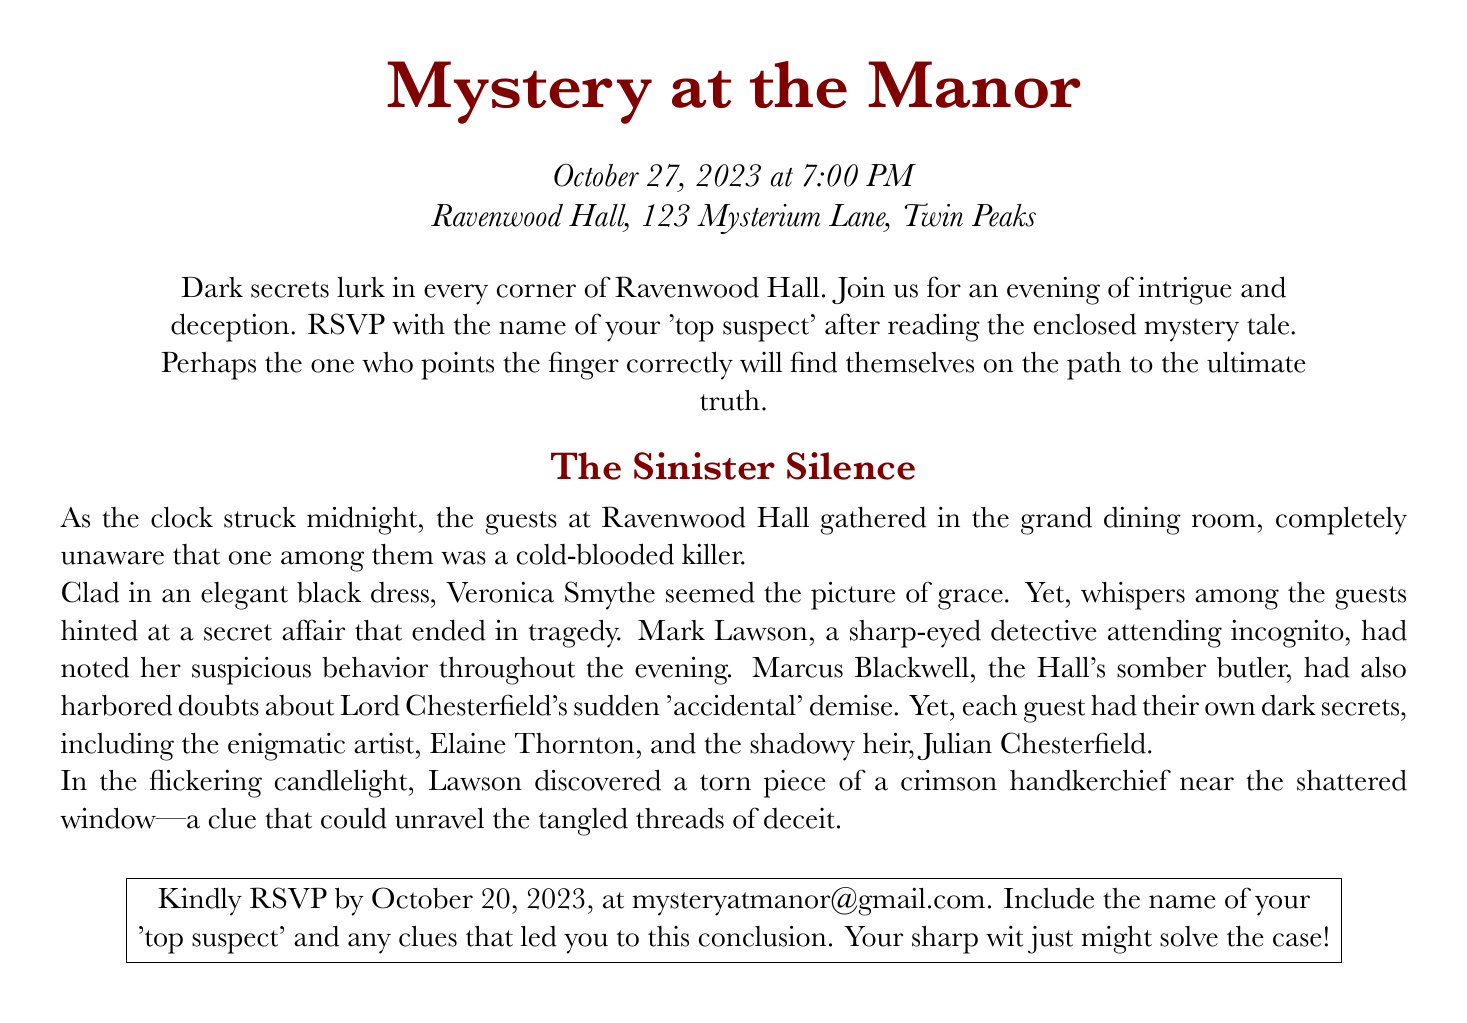What is the title of the event? The title of the event is prominently displayed at the top of the RSVP card, indicating the theme of the evening.
Answer: Mystery at the Manor When is the event taking place? The date and time of the event are specified in a clear format on the RSVP card.
Answer: October 27, 2023 at 7:00 PM What is the venue of the dinner party? The RSVP card includes the location of the event, which is essential for guests to know where to go.
Answer: Ravenwood Hall, 123 Mysterium Lane, Twin Peaks What should guests include in their RSVP? The RSVP card instructs guests on what to confirm in their responses, essential for participation.
Answer: Name of your 'top suspect' When is the RSVP deadline? The RSVP card clearly states the deadline for guests to respond, crucial for planning purposes.
Answer: October 20, 2023 What color is associated with the document? A specific color is used throughout the RSVP card to enhance the theme and mood of the event.
Answer: mysteryred Who is the sharp-eyed detective? The document provides a character in the mystery narrative that guests may identify with while investigating.
Answer: Mark Lawson What clue is mentioned near the shattered window? The RSVP card reveals a significant detail from the story, which can lead guests to their conclusions.
Answer: Torn piece of a crimson handkerchief What literary genre does this event represent? The RSVP card conveys the theme of the event, indicating its storyline and mood for the night.
Answer: Murder mystery 